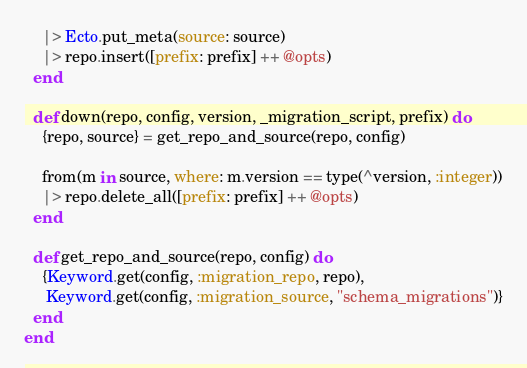Convert code to text. <code><loc_0><loc_0><loc_500><loc_500><_Elixir_>    |> Ecto.put_meta(source: source)
    |> repo.insert([prefix: prefix] ++ @opts)
  end

  def down(repo, config, version, _migration_script, prefix) do
    {repo, source} = get_repo_and_source(repo, config)

    from(m in source, where: m.version == type(^version, :integer))
    |> repo.delete_all([prefix: prefix] ++ @opts)
  end

  def get_repo_and_source(repo, config) do
    {Keyword.get(config, :migration_repo, repo),
     Keyword.get(config, :migration_source, "schema_migrations")}
  end
end
</code> 